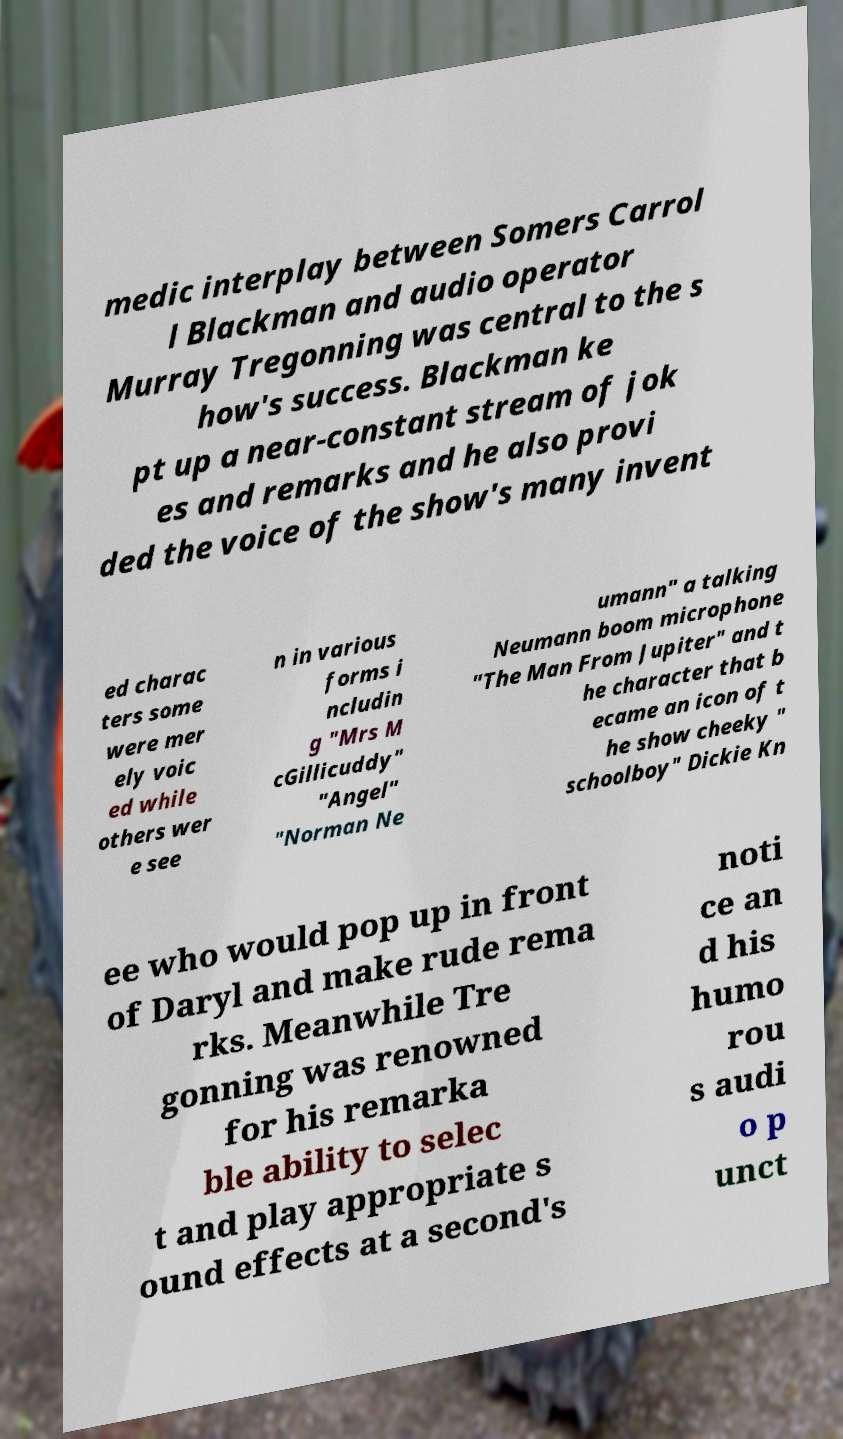I need the written content from this picture converted into text. Can you do that? medic interplay between Somers Carrol l Blackman and audio operator Murray Tregonning was central to the s how's success. Blackman ke pt up a near-constant stream of jok es and remarks and he also provi ded the voice of the show's many invent ed charac ters some were mer ely voic ed while others wer e see n in various forms i ncludin g "Mrs M cGillicuddy" "Angel" "Norman Ne umann" a talking Neumann boom microphone "The Man From Jupiter" and t he character that b ecame an icon of t he show cheeky " schoolboy" Dickie Kn ee who would pop up in front of Daryl and make rude rema rks. Meanwhile Tre gonning was renowned for his remarka ble ability to selec t and play appropriate s ound effects at a second's noti ce an d his humo rou s audi o p unct 